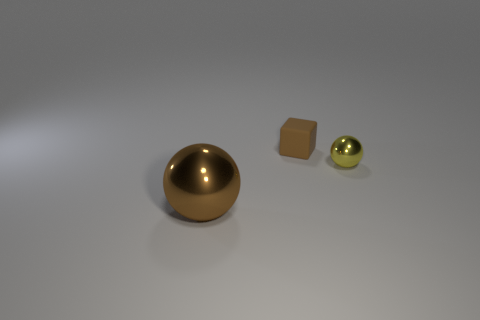Add 2 tiny spheres. How many objects exist? 5 Subtract all balls. How many objects are left? 1 Subtract all small yellow things. Subtract all large brown spheres. How many objects are left? 1 Add 2 small yellow shiny objects. How many small yellow shiny objects are left? 3 Add 2 small purple shiny things. How many small purple shiny things exist? 2 Subtract 0 blue cubes. How many objects are left? 3 